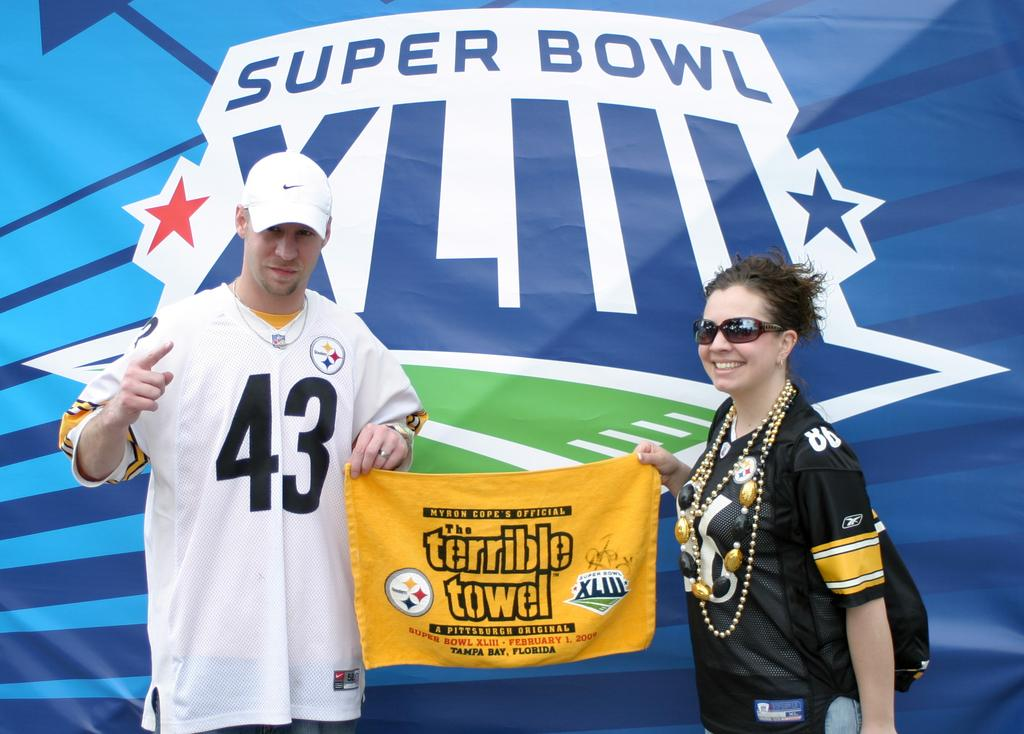<image>
Describe the image concisely. A man with a white #43 jersey and a woman hold a banner that says "The Terrible Towel" with a banner for Super Bowl XLIII in the background. 